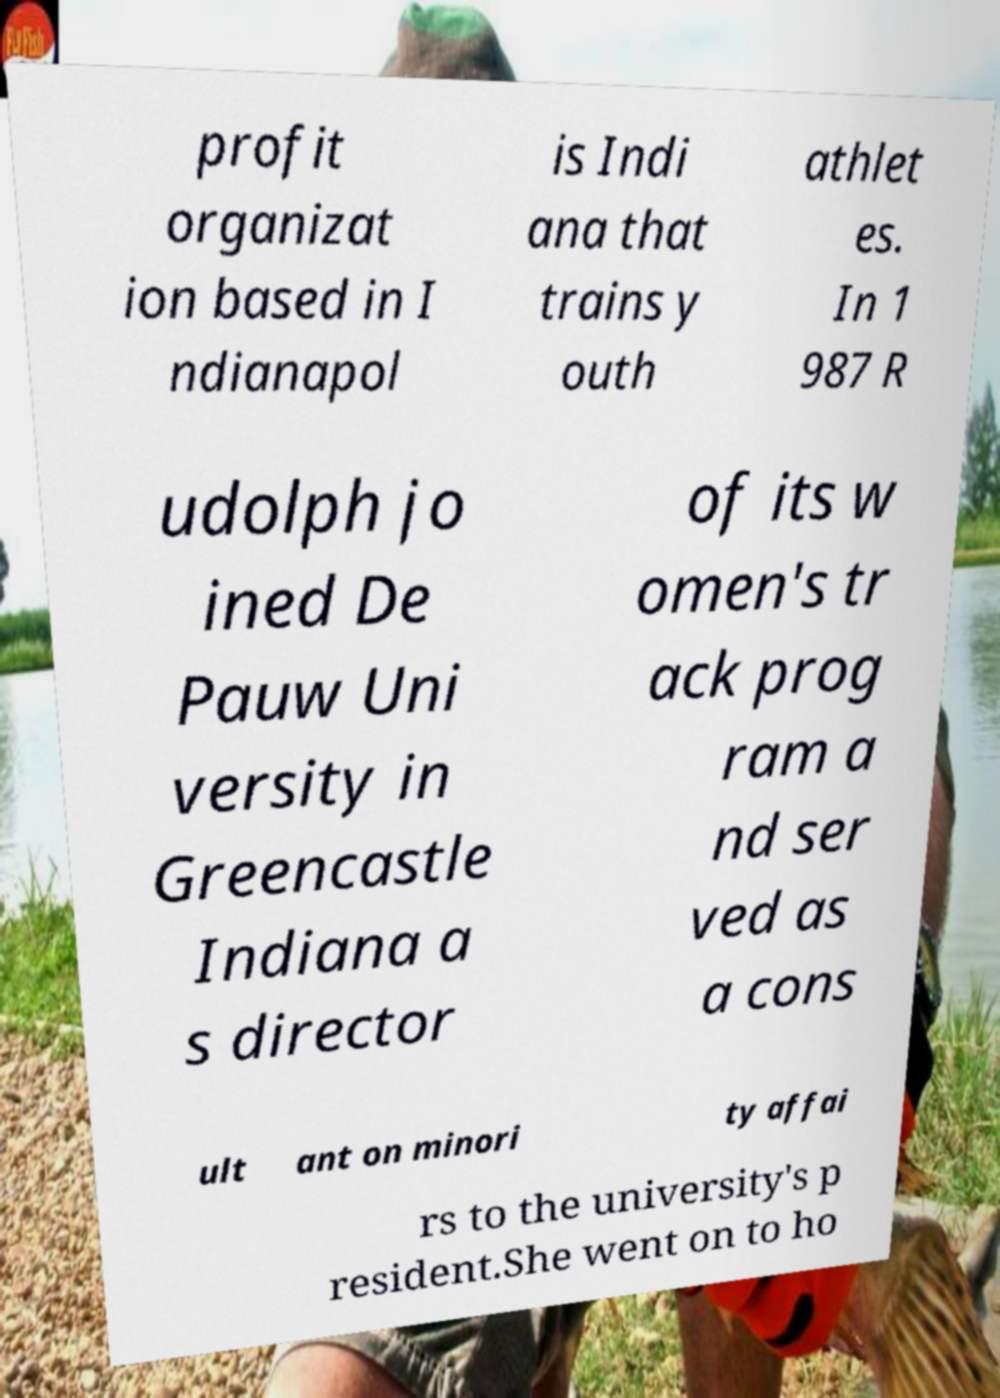Can you read and provide the text displayed in the image?This photo seems to have some interesting text. Can you extract and type it out for me? profit organizat ion based in I ndianapol is Indi ana that trains y outh athlet es. In 1 987 R udolph jo ined De Pauw Uni versity in Greencastle Indiana a s director of its w omen's tr ack prog ram a nd ser ved as a cons ult ant on minori ty affai rs to the university's p resident.She went on to ho 